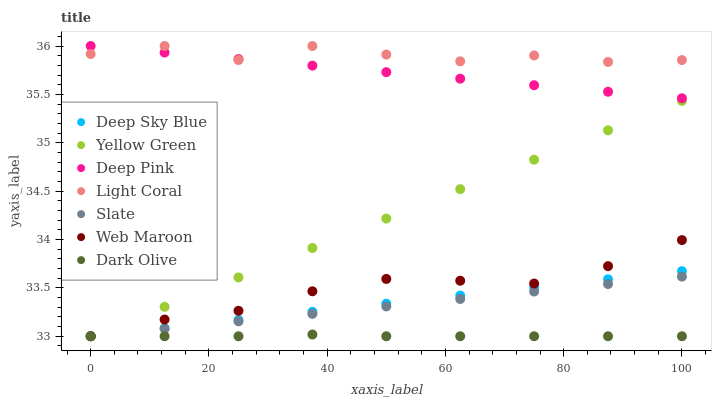Does Dark Olive have the minimum area under the curve?
Answer yes or no. Yes. Does Light Coral have the maximum area under the curve?
Answer yes or no. Yes. Does Yellow Green have the minimum area under the curve?
Answer yes or no. No. Does Yellow Green have the maximum area under the curve?
Answer yes or no. No. Is Yellow Green the smoothest?
Answer yes or no. Yes. Is Light Coral the roughest?
Answer yes or no. Yes. Is Slate the smoothest?
Answer yes or no. No. Is Slate the roughest?
Answer yes or no. No. Does Yellow Green have the lowest value?
Answer yes or no. Yes. Does Light Coral have the lowest value?
Answer yes or no. No. Does Light Coral have the highest value?
Answer yes or no. Yes. Does Yellow Green have the highest value?
Answer yes or no. No. Is Dark Olive less than Light Coral?
Answer yes or no. Yes. Is Light Coral greater than Web Maroon?
Answer yes or no. Yes. Does Deep Sky Blue intersect Dark Olive?
Answer yes or no. Yes. Is Deep Sky Blue less than Dark Olive?
Answer yes or no. No. Is Deep Sky Blue greater than Dark Olive?
Answer yes or no. No. Does Dark Olive intersect Light Coral?
Answer yes or no. No. 